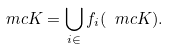Convert formula to latex. <formula><loc_0><loc_0><loc_500><loc_500>\ m c { K } = \bigcup _ { i \in \L } f _ { i } ( \ m c { K } ) .</formula> 